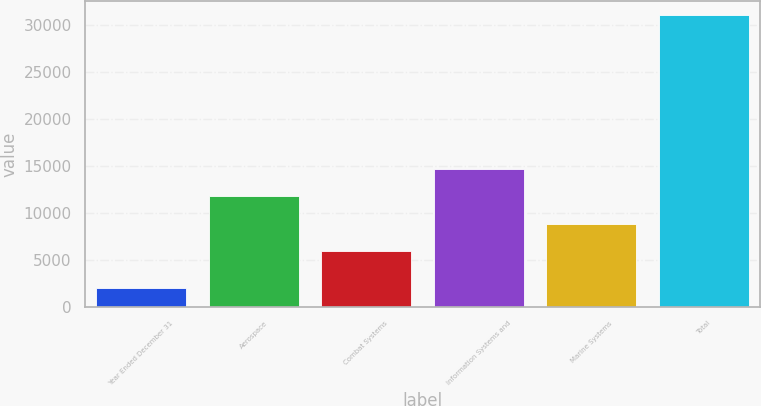Convert chart to OTSL. <chart><loc_0><loc_0><loc_500><loc_500><bar_chart><fcel>Year Ended December 31<fcel>Aerospace<fcel>Combat Systems<fcel>Information Systems and<fcel>Marine Systems<fcel>Total<nl><fcel>2017<fcel>11740.2<fcel>5949<fcel>14635.8<fcel>8844.6<fcel>30973<nl></chart> 